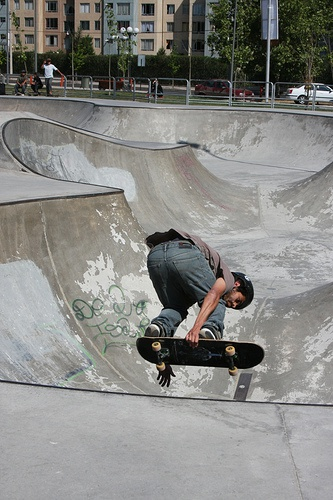Describe the objects in this image and their specific colors. I can see people in black, gray, and darkgray tones, skateboard in black, darkgray, gray, and tan tones, car in black, lightgray, gray, and darkgray tones, car in black, maroon, and gray tones, and bench in black, gray, and darkgray tones in this image. 